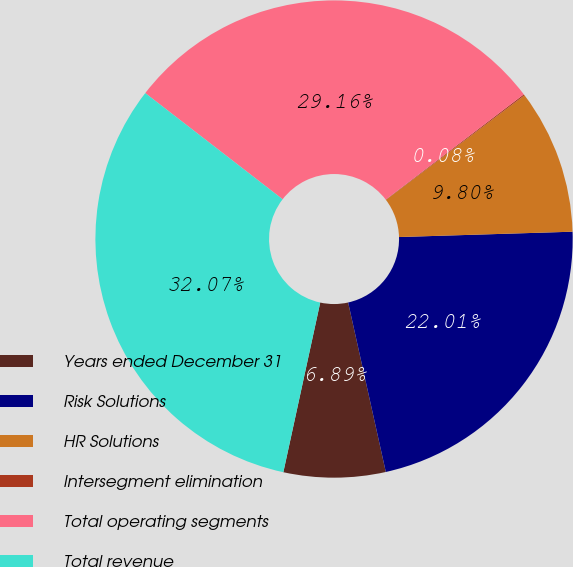Convert chart to OTSL. <chart><loc_0><loc_0><loc_500><loc_500><pie_chart><fcel>Years ended December 31<fcel>Risk Solutions<fcel>HR Solutions<fcel>Intersegment elimination<fcel>Total operating segments<fcel>Total revenue<nl><fcel>6.89%<fcel>22.01%<fcel>9.8%<fcel>0.08%<fcel>29.16%<fcel>32.07%<nl></chart> 